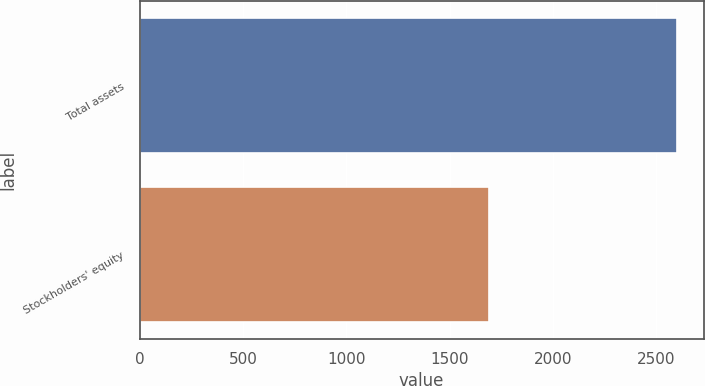Convert chart to OTSL. <chart><loc_0><loc_0><loc_500><loc_500><bar_chart><fcel>Total assets<fcel>Stockholders' equity<nl><fcel>2599<fcel>1691<nl></chart> 